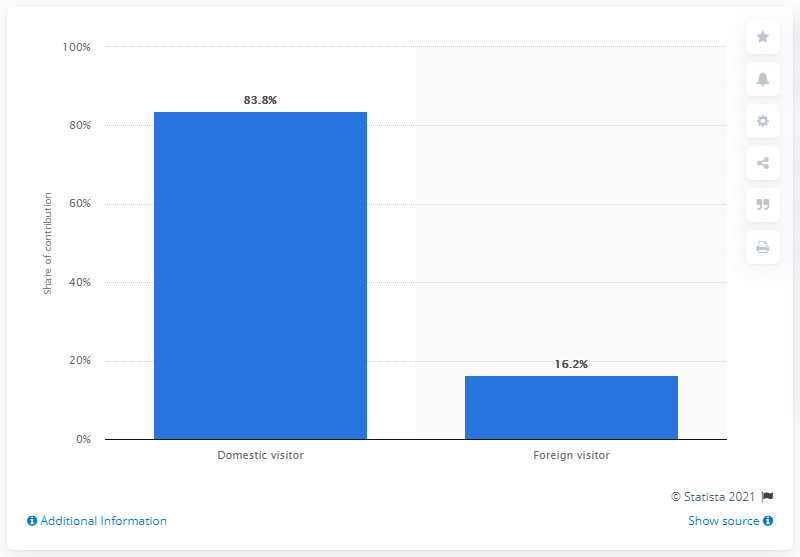List a handful of essential elements in this visual. In 2017, domestic travel spending in Mexico accounted for 83.8% of the total direct travel and tourism GDP. 